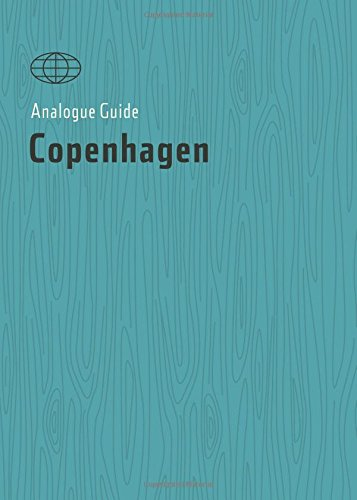Is this book related to Travel? Absolutely, this book is a travel guide geared towards helping adventurers uncover the best experiences in Copenhagen. 